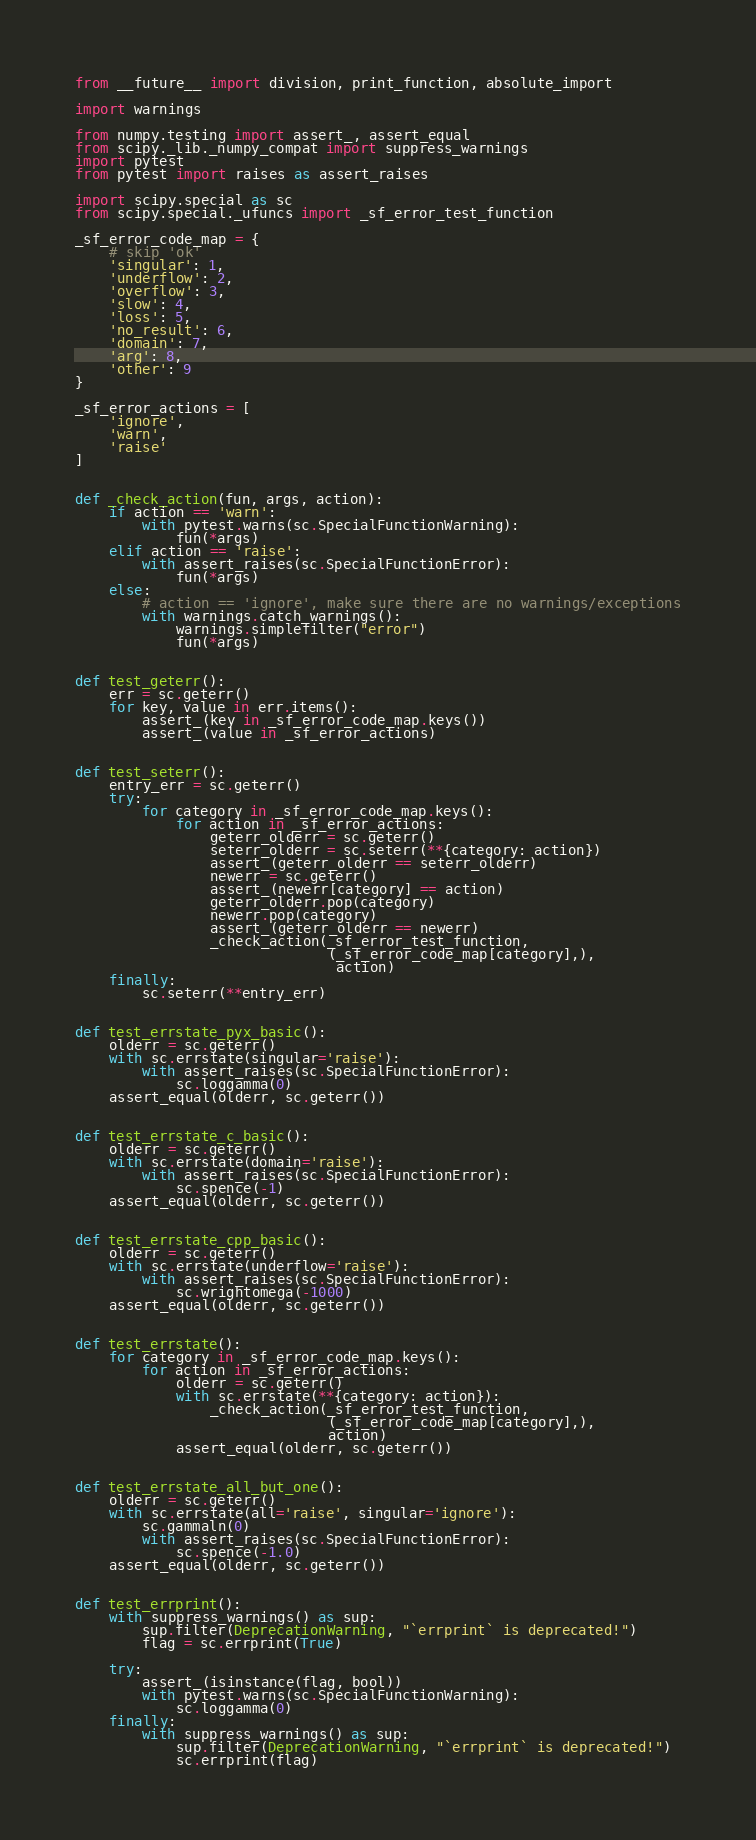Convert code to text. <code><loc_0><loc_0><loc_500><loc_500><_Python_>from __future__ import division, print_function, absolute_import

import warnings

from numpy.testing import assert_, assert_equal
from scipy._lib._numpy_compat import suppress_warnings
import pytest
from pytest import raises as assert_raises

import scipy.special as sc
from scipy.special._ufuncs import _sf_error_test_function

_sf_error_code_map = {
    # skip 'ok'
    'singular': 1,
    'underflow': 2,
    'overflow': 3,
    'slow': 4,
    'loss': 5,
    'no_result': 6,
    'domain': 7,
    'arg': 8,
    'other': 9
}

_sf_error_actions = [
    'ignore',
    'warn',
    'raise'
]


def _check_action(fun, args, action):
    if action == 'warn':
        with pytest.warns(sc.SpecialFunctionWarning):
            fun(*args)
    elif action == 'raise':
        with assert_raises(sc.SpecialFunctionError):
            fun(*args)
    else:
        # action == 'ignore', make sure there are no warnings/exceptions
        with warnings.catch_warnings():
            warnings.simplefilter("error")
            fun(*args)


def test_geterr():
    err = sc.geterr()
    for key, value in err.items():
        assert_(key in _sf_error_code_map.keys())
        assert_(value in _sf_error_actions)


def test_seterr():
    entry_err = sc.geterr()
    try:
        for category in _sf_error_code_map.keys():
            for action in _sf_error_actions:
                geterr_olderr = sc.geterr()
                seterr_olderr = sc.seterr(**{category: action})
                assert_(geterr_olderr == seterr_olderr)
                newerr = sc.geterr()
                assert_(newerr[category] == action)
                geterr_olderr.pop(category)
                newerr.pop(category)
                assert_(geterr_olderr == newerr)
                _check_action(_sf_error_test_function,
                              (_sf_error_code_map[category],),
                               action)
    finally:
        sc.seterr(**entry_err)


def test_errstate_pyx_basic():
    olderr = sc.geterr()
    with sc.errstate(singular='raise'):
        with assert_raises(sc.SpecialFunctionError):
            sc.loggamma(0)
    assert_equal(olderr, sc.geterr())


def test_errstate_c_basic():
    olderr = sc.geterr()
    with sc.errstate(domain='raise'):
        with assert_raises(sc.SpecialFunctionError):
            sc.spence(-1)
    assert_equal(olderr, sc.geterr())


def test_errstate_cpp_basic():
    olderr = sc.geterr()
    with sc.errstate(underflow='raise'):
        with assert_raises(sc.SpecialFunctionError):
            sc.wrightomega(-1000)
    assert_equal(olderr, sc.geterr())


def test_errstate():
    for category in _sf_error_code_map.keys():
        for action in _sf_error_actions:
            olderr = sc.geterr()
            with sc.errstate(**{category: action}):
                _check_action(_sf_error_test_function,
                              (_sf_error_code_map[category],),
                              action)
            assert_equal(olderr, sc.geterr())


def test_errstate_all_but_one():
    olderr = sc.geterr()
    with sc.errstate(all='raise', singular='ignore'):
        sc.gammaln(0)
        with assert_raises(sc.SpecialFunctionError):
            sc.spence(-1.0)
    assert_equal(olderr, sc.geterr())


def test_errprint():
    with suppress_warnings() as sup:
        sup.filter(DeprecationWarning, "`errprint` is deprecated!")
        flag = sc.errprint(True)

    try:
        assert_(isinstance(flag, bool))
        with pytest.warns(sc.SpecialFunctionWarning):
            sc.loggamma(0)
    finally:
        with suppress_warnings() as sup:
            sup.filter(DeprecationWarning, "`errprint` is deprecated!")
            sc.errprint(flag)
</code> 